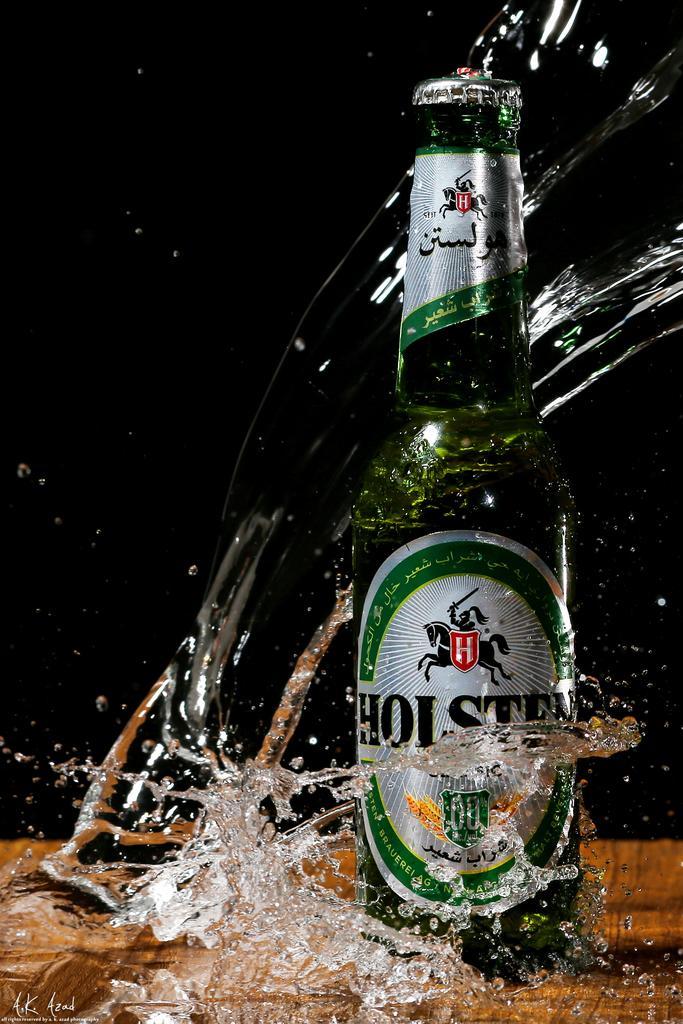How would you summarize this image in a sentence or two? In this image we can see a bottle on a surface, also we can see some water, and the background is blurred. 